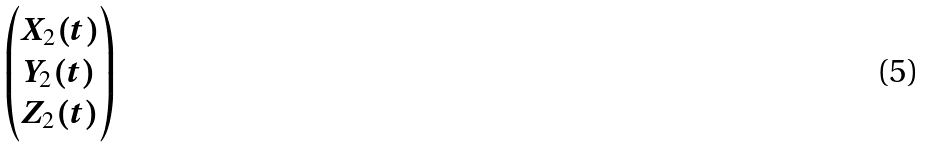Convert formula to latex. <formula><loc_0><loc_0><loc_500><loc_500>\begin{pmatrix} X _ { 2 } ( t ) \\ Y _ { 2 } ( t ) \\ Z _ { 2 } ( t ) \\ \end{pmatrix}</formula> 